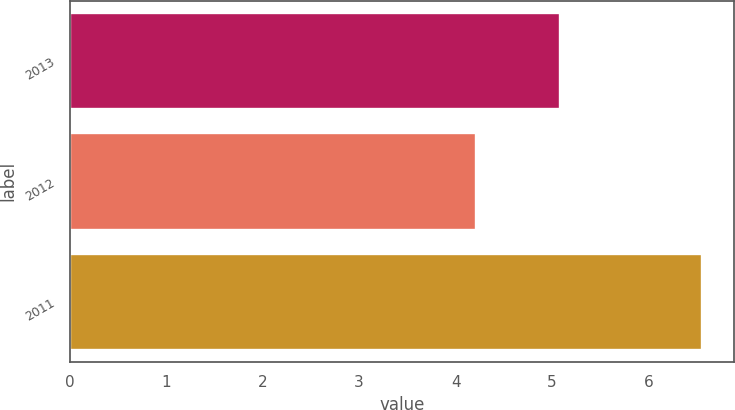Convert chart to OTSL. <chart><loc_0><loc_0><loc_500><loc_500><bar_chart><fcel>2013<fcel>2012<fcel>2011<nl><fcel>5.08<fcel>4.21<fcel>6.56<nl></chart> 